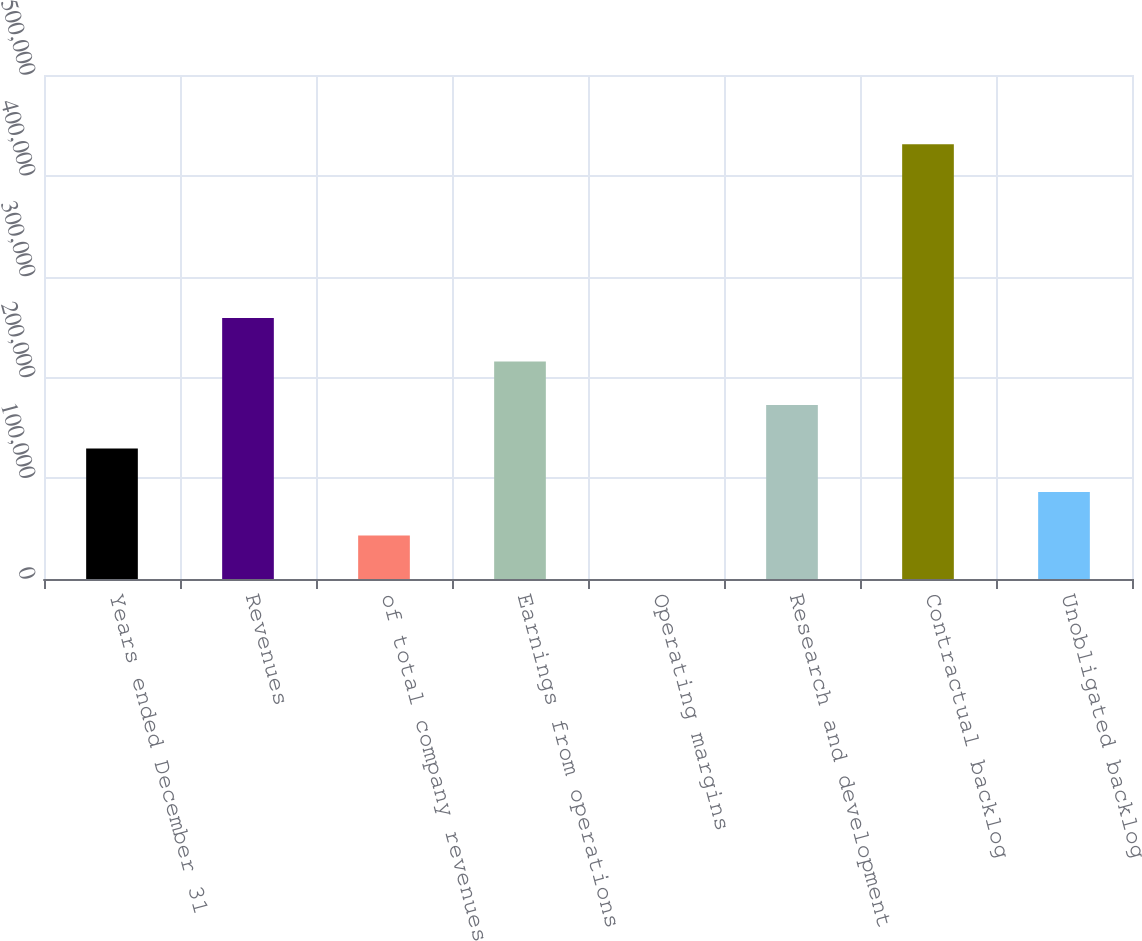Convert chart to OTSL. <chart><loc_0><loc_0><loc_500><loc_500><bar_chart><fcel>Years ended December 31<fcel>Revenues<fcel>of total company revenues<fcel>Earnings from operations<fcel>Operating margins<fcel>Research and development<fcel>Contractual backlog<fcel>Unobligated backlog<nl><fcel>129428<fcel>258848<fcel>43147.8<fcel>215708<fcel>7.8<fcel>172568<fcel>431408<fcel>86287.8<nl></chart> 